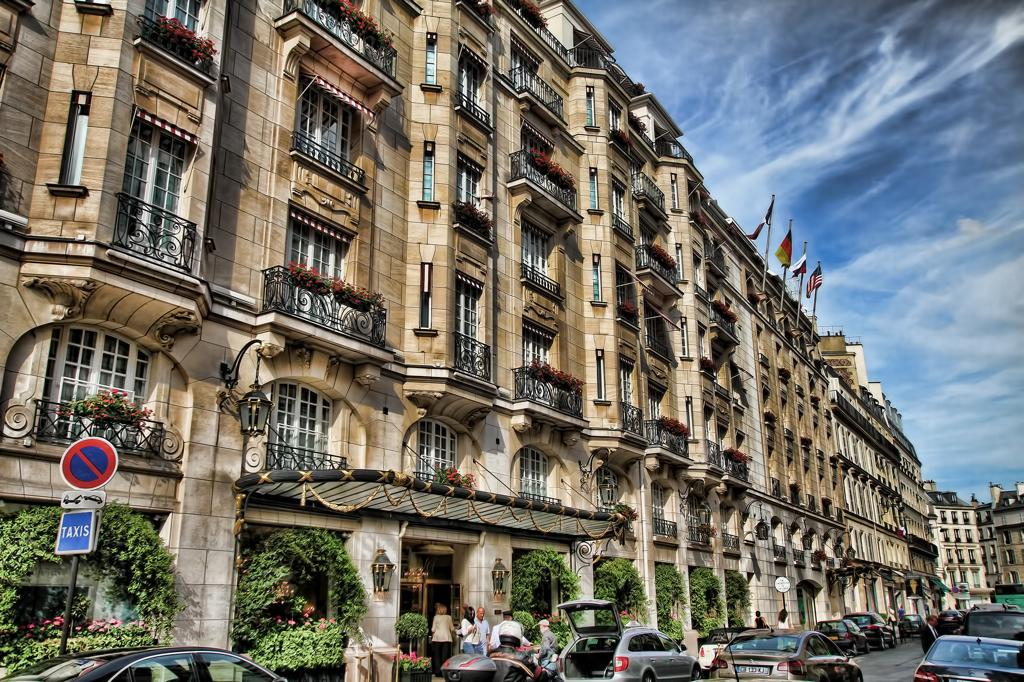What can be seen on the road in the image? There are cars parked on the road. What are the people in the image doing? There is a group of people standing on the path. What can be seen in the distance in the image? There are buildings visible in the background. How would you describe the weather in the image? The sky is cloudy in the image. Where are the tomatoes being grown in the image? There are no tomatoes present in the image. What is the yoke used for in the image? There is no yoke present in the image. 